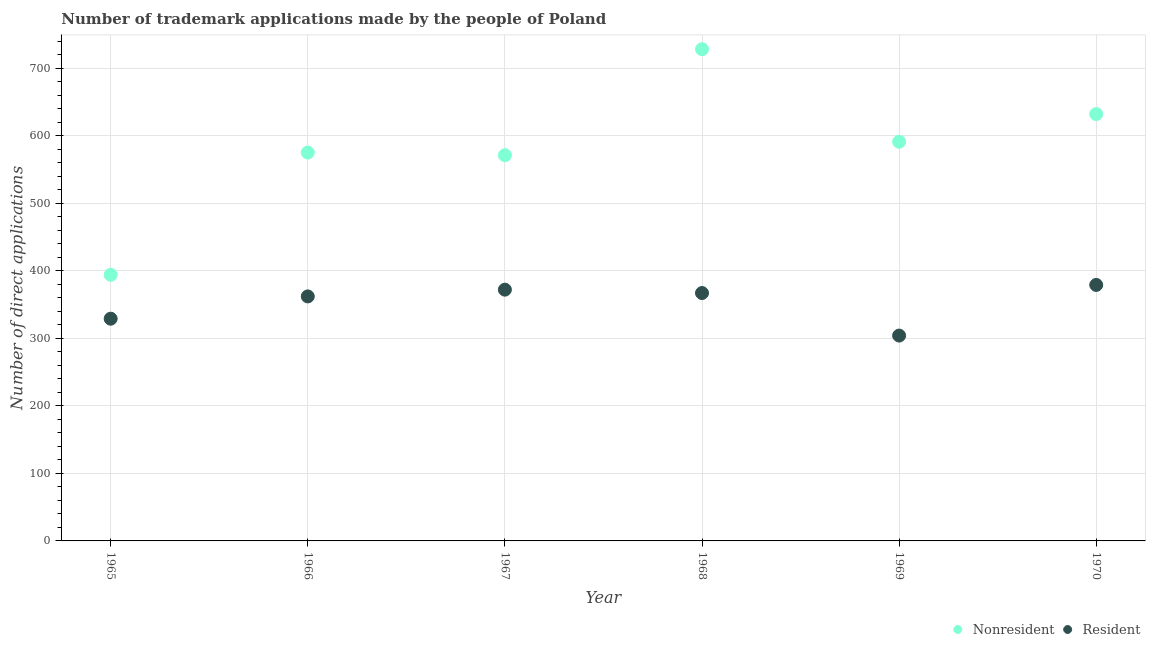What is the number of trademark applications made by non residents in 1969?
Provide a succinct answer. 591. Across all years, what is the maximum number of trademark applications made by non residents?
Offer a very short reply. 728. Across all years, what is the minimum number of trademark applications made by non residents?
Your answer should be very brief. 394. In which year was the number of trademark applications made by non residents minimum?
Keep it short and to the point. 1965. What is the total number of trademark applications made by non residents in the graph?
Your response must be concise. 3491. What is the difference between the number of trademark applications made by residents in 1967 and that in 1968?
Your response must be concise. 5. What is the difference between the number of trademark applications made by residents in 1969 and the number of trademark applications made by non residents in 1970?
Your answer should be very brief. -328. What is the average number of trademark applications made by non residents per year?
Make the answer very short. 581.83. In the year 1967, what is the difference between the number of trademark applications made by non residents and number of trademark applications made by residents?
Make the answer very short. 199. In how many years, is the number of trademark applications made by residents greater than 480?
Offer a terse response. 0. What is the ratio of the number of trademark applications made by residents in 1966 to that in 1970?
Keep it short and to the point. 0.96. Is the number of trademark applications made by residents in 1968 less than that in 1969?
Offer a terse response. No. Is the difference between the number of trademark applications made by residents in 1966 and 1969 greater than the difference between the number of trademark applications made by non residents in 1966 and 1969?
Your answer should be very brief. Yes. What is the difference between the highest and the second highest number of trademark applications made by non residents?
Your response must be concise. 96. What is the difference between the highest and the lowest number of trademark applications made by residents?
Ensure brevity in your answer.  75. Is the sum of the number of trademark applications made by residents in 1965 and 1967 greater than the maximum number of trademark applications made by non residents across all years?
Keep it short and to the point. No. Does the number of trademark applications made by non residents monotonically increase over the years?
Keep it short and to the point. No. Is the number of trademark applications made by residents strictly less than the number of trademark applications made by non residents over the years?
Make the answer very short. Yes. How many dotlines are there?
Provide a short and direct response. 2. How many years are there in the graph?
Give a very brief answer. 6. Are the values on the major ticks of Y-axis written in scientific E-notation?
Provide a short and direct response. No. Does the graph contain any zero values?
Offer a terse response. No. How many legend labels are there?
Keep it short and to the point. 2. How are the legend labels stacked?
Ensure brevity in your answer.  Horizontal. What is the title of the graph?
Your answer should be very brief. Number of trademark applications made by the people of Poland. What is the label or title of the Y-axis?
Offer a very short reply. Number of direct applications. What is the Number of direct applications of Nonresident in 1965?
Your response must be concise. 394. What is the Number of direct applications in Resident in 1965?
Keep it short and to the point. 329. What is the Number of direct applications of Nonresident in 1966?
Your response must be concise. 575. What is the Number of direct applications in Resident in 1966?
Offer a very short reply. 362. What is the Number of direct applications of Nonresident in 1967?
Your answer should be very brief. 571. What is the Number of direct applications in Resident in 1967?
Offer a very short reply. 372. What is the Number of direct applications of Nonresident in 1968?
Provide a short and direct response. 728. What is the Number of direct applications of Resident in 1968?
Give a very brief answer. 367. What is the Number of direct applications in Nonresident in 1969?
Your answer should be very brief. 591. What is the Number of direct applications in Resident in 1969?
Provide a short and direct response. 304. What is the Number of direct applications in Nonresident in 1970?
Provide a short and direct response. 632. What is the Number of direct applications in Resident in 1970?
Your answer should be very brief. 379. Across all years, what is the maximum Number of direct applications of Nonresident?
Provide a short and direct response. 728. Across all years, what is the maximum Number of direct applications of Resident?
Offer a terse response. 379. Across all years, what is the minimum Number of direct applications in Nonresident?
Provide a short and direct response. 394. Across all years, what is the minimum Number of direct applications in Resident?
Provide a succinct answer. 304. What is the total Number of direct applications of Nonresident in the graph?
Keep it short and to the point. 3491. What is the total Number of direct applications in Resident in the graph?
Your answer should be very brief. 2113. What is the difference between the Number of direct applications of Nonresident in 1965 and that in 1966?
Give a very brief answer. -181. What is the difference between the Number of direct applications of Resident in 1965 and that in 1966?
Give a very brief answer. -33. What is the difference between the Number of direct applications of Nonresident in 1965 and that in 1967?
Offer a terse response. -177. What is the difference between the Number of direct applications in Resident in 1965 and that in 1967?
Your answer should be compact. -43. What is the difference between the Number of direct applications in Nonresident in 1965 and that in 1968?
Offer a very short reply. -334. What is the difference between the Number of direct applications of Resident in 1965 and that in 1968?
Provide a short and direct response. -38. What is the difference between the Number of direct applications in Nonresident in 1965 and that in 1969?
Your response must be concise. -197. What is the difference between the Number of direct applications in Nonresident in 1965 and that in 1970?
Your response must be concise. -238. What is the difference between the Number of direct applications in Resident in 1965 and that in 1970?
Ensure brevity in your answer.  -50. What is the difference between the Number of direct applications of Resident in 1966 and that in 1967?
Offer a very short reply. -10. What is the difference between the Number of direct applications of Nonresident in 1966 and that in 1968?
Provide a succinct answer. -153. What is the difference between the Number of direct applications of Resident in 1966 and that in 1968?
Provide a succinct answer. -5. What is the difference between the Number of direct applications of Nonresident in 1966 and that in 1969?
Your answer should be very brief. -16. What is the difference between the Number of direct applications of Nonresident in 1966 and that in 1970?
Make the answer very short. -57. What is the difference between the Number of direct applications of Resident in 1966 and that in 1970?
Provide a short and direct response. -17. What is the difference between the Number of direct applications in Nonresident in 1967 and that in 1968?
Offer a terse response. -157. What is the difference between the Number of direct applications of Resident in 1967 and that in 1968?
Your answer should be very brief. 5. What is the difference between the Number of direct applications of Resident in 1967 and that in 1969?
Your response must be concise. 68. What is the difference between the Number of direct applications of Nonresident in 1967 and that in 1970?
Offer a terse response. -61. What is the difference between the Number of direct applications of Nonresident in 1968 and that in 1969?
Your answer should be compact. 137. What is the difference between the Number of direct applications in Nonresident in 1968 and that in 1970?
Your answer should be compact. 96. What is the difference between the Number of direct applications in Resident in 1968 and that in 1970?
Give a very brief answer. -12. What is the difference between the Number of direct applications in Nonresident in 1969 and that in 1970?
Give a very brief answer. -41. What is the difference between the Number of direct applications in Resident in 1969 and that in 1970?
Your answer should be compact. -75. What is the difference between the Number of direct applications of Nonresident in 1965 and the Number of direct applications of Resident in 1966?
Your answer should be compact. 32. What is the difference between the Number of direct applications of Nonresident in 1965 and the Number of direct applications of Resident in 1967?
Your answer should be compact. 22. What is the difference between the Number of direct applications of Nonresident in 1965 and the Number of direct applications of Resident in 1969?
Provide a succinct answer. 90. What is the difference between the Number of direct applications in Nonresident in 1966 and the Number of direct applications in Resident in 1967?
Keep it short and to the point. 203. What is the difference between the Number of direct applications of Nonresident in 1966 and the Number of direct applications of Resident in 1968?
Offer a very short reply. 208. What is the difference between the Number of direct applications in Nonresident in 1966 and the Number of direct applications in Resident in 1969?
Give a very brief answer. 271. What is the difference between the Number of direct applications of Nonresident in 1966 and the Number of direct applications of Resident in 1970?
Give a very brief answer. 196. What is the difference between the Number of direct applications in Nonresident in 1967 and the Number of direct applications in Resident in 1968?
Provide a succinct answer. 204. What is the difference between the Number of direct applications of Nonresident in 1967 and the Number of direct applications of Resident in 1969?
Keep it short and to the point. 267. What is the difference between the Number of direct applications in Nonresident in 1967 and the Number of direct applications in Resident in 1970?
Keep it short and to the point. 192. What is the difference between the Number of direct applications in Nonresident in 1968 and the Number of direct applications in Resident in 1969?
Keep it short and to the point. 424. What is the difference between the Number of direct applications of Nonresident in 1968 and the Number of direct applications of Resident in 1970?
Give a very brief answer. 349. What is the difference between the Number of direct applications in Nonresident in 1969 and the Number of direct applications in Resident in 1970?
Give a very brief answer. 212. What is the average Number of direct applications in Nonresident per year?
Your response must be concise. 581.83. What is the average Number of direct applications in Resident per year?
Keep it short and to the point. 352.17. In the year 1966, what is the difference between the Number of direct applications of Nonresident and Number of direct applications of Resident?
Make the answer very short. 213. In the year 1967, what is the difference between the Number of direct applications in Nonresident and Number of direct applications in Resident?
Provide a short and direct response. 199. In the year 1968, what is the difference between the Number of direct applications of Nonresident and Number of direct applications of Resident?
Ensure brevity in your answer.  361. In the year 1969, what is the difference between the Number of direct applications in Nonresident and Number of direct applications in Resident?
Your response must be concise. 287. In the year 1970, what is the difference between the Number of direct applications of Nonresident and Number of direct applications of Resident?
Provide a short and direct response. 253. What is the ratio of the Number of direct applications of Nonresident in 1965 to that in 1966?
Give a very brief answer. 0.69. What is the ratio of the Number of direct applications in Resident in 1965 to that in 1966?
Make the answer very short. 0.91. What is the ratio of the Number of direct applications in Nonresident in 1965 to that in 1967?
Your answer should be compact. 0.69. What is the ratio of the Number of direct applications of Resident in 1965 to that in 1967?
Provide a short and direct response. 0.88. What is the ratio of the Number of direct applications in Nonresident in 1965 to that in 1968?
Offer a terse response. 0.54. What is the ratio of the Number of direct applications of Resident in 1965 to that in 1968?
Give a very brief answer. 0.9. What is the ratio of the Number of direct applications in Resident in 1965 to that in 1969?
Keep it short and to the point. 1.08. What is the ratio of the Number of direct applications in Nonresident in 1965 to that in 1970?
Offer a terse response. 0.62. What is the ratio of the Number of direct applications in Resident in 1965 to that in 1970?
Make the answer very short. 0.87. What is the ratio of the Number of direct applications in Resident in 1966 to that in 1967?
Provide a short and direct response. 0.97. What is the ratio of the Number of direct applications of Nonresident in 1966 to that in 1968?
Give a very brief answer. 0.79. What is the ratio of the Number of direct applications of Resident in 1966 to that in 1968?
Offer a very short reply. 0.99. What is the ratio of the Number of direct applications in Nonresident in 1966 to that in 1969?
Your answer should be very brief. 0.97. What is the ratio of the Number of direct applications of Resident in 1966 to that in 1969?
Keep it short and to the point. 1.19. What is the ratio of the Number of direct applications in Nonresident in 1966 to that in 1970?
Offer a terse response. 0.91. What is the ratio of the Number of direct applications in Resident in 1966 to that in 1970?
Keep it short and to the point. 0.96. What is the ratio of the Number of direct applications in Nonresident in 1967 to that in 1968?
Make the answer very short. 0.78. What is the ratio of the Number of direct applications of Resident in 1967 to that in 1968?
Your response must be concise. 1.01. What is the ratio of the Number of direct applications of Nonresident in 1967 to that in 1969?
Your answer should be compact. 0.97. What is the ratio of the Number of direct applications of Resident in 1967 to that in 1969?
Give a very brief answer. 1.22. What is the ratio of the Number of direct applications of Nonresident in 1967 to that in 1970?
Offer a terse response. 0.9. What is the ratio of the Number of direct applications in Resident in 1967 to that in 1970?
Your answer should be very brief. 0.98. What is the ratio of the Number of direct applications in Nonresident in 1968 to that in 1969?
Your answer should be very brief. 1.23. What is the ratio of the Number of direct applications in Resident in 1968 to that in 1969?
Provide a short and direct response. 1.21. What is the ratio of the Number of direct applications of Nonresident in 1968 to that in 1970?
Provide a succinct answer. 1.15. What is the ratio of the Number of direct applications in Resident in 1968 to that in 1970?
Provide a succinct answer. 0.97. What is the ratio of the Number of direct applications in Nonresident in 1969 to that in 1970?
Ensure brevity in your answer.  0.94. What is the ratio of the Number of direct applications of Resident in 1969 to that in 1970?
Provide a succinct answer. 0.8. What is the difference between the highest and the second highest Number of direct applications in Nonresident?
Provide a short and direct response. 96. What is the difference between the highest and the lowest Number of direct applications in Nonresident?
Make the answer very short. 334. What is the difference between the highest and the lowest Number of direct applications in Resident?
Your answer should be very brief. 75. 